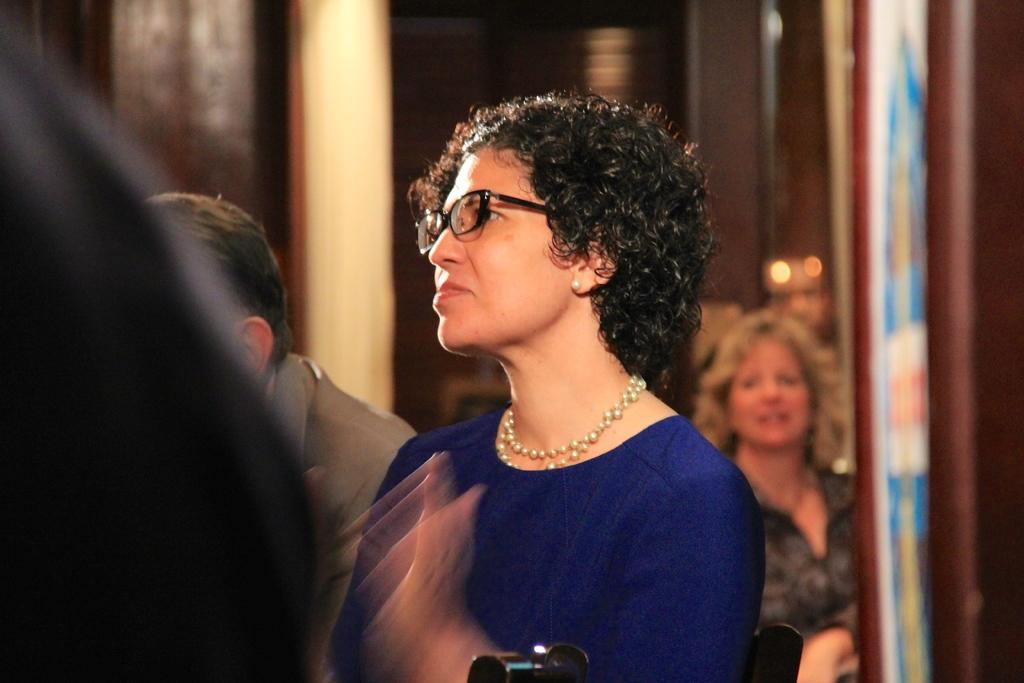Who is the main subject in the image? There is a woman in the image. What is the woman wearing on her face? The woman is wearing spectacles. Can you describe the surrounding environment in the image? There are people visible around the woman. What system is the woman using to drop objects in the image? There is no system or object-dropping activity depicted in the image. 